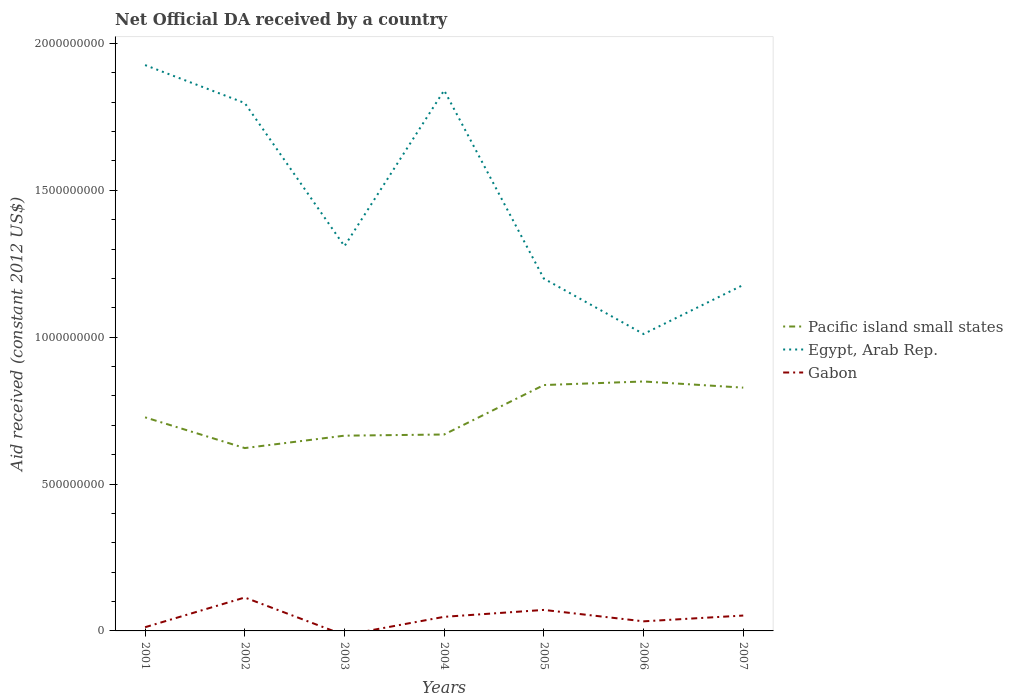How many different coloured lines are there?
Your answer should be compact. 3. Across all years, what is the maximum net official development assistance aid received in Egypt, Arab Rep.?
Make the answer very short. 1.01e+09. What is the total net official development assistance aid received in Pacific island small states in the graph?
Keep it short and to the point. -2.27e+08. What is the difference between the highest and the second highest net official development assistance aid received in Egypt, Arab Rep.?
Your response must be concise. 9.16e+08. What is the difference between the highest and the lowest net official development assistance aid received in Egypt, Arab Rep.?
Make the answer very short. 3. Is the net official development assistance aid received in Egypt, Arab Rep. strictly greater than the net official development assistance aid received in Pacific island small states over the years?
Provide a short and direct response. No. How many lines are there?
Your answer should be compact. 3. Where does the legend appear in the graph?
Offer a terse response. Center right. How are the legend labels stacked?
Offer a very short reply. Vertical. What is the title of the graph?
Your answer should be compact. Net Official DA received by a country. Does "Kiribati" appear as one of the legend labels in the graph?
Your answer should be very brief. No. What is the label or title of the X-axis?
Your answer should be compact. Years. What is the label or title of the Y-axis?
Ensure brevity in your answer.  Aid received (constant 2012 US$). What is the Aid received (constant 2012 US$) in Pacific island small states in 2001?
Provide a short and direct response. 7.27e+08. What is the Aid received (constant 2012 US$) of Egypt, Arab Rep. in 2001?
Provide a short and direct response. 1.93e+09. What is the Aid received (constant 2012 US$) of Gabon in 2001?
Offer a terse response. 1.26e+07. What is the Aid received (constant 2012 US$) in Pacific island small states in 2002?
Ensure brevity in your answer.  6.22e+08. What is the Aid received (constant 2012 US$) in Egypt, Arab Rep. in 2002?
Keep it short and to the point. 1.80e+09. What is the Aid received (constant 2012 US$) of Gabon in 2002?
Provide a succinct answer. 1.14e+08. What is the Aid received (constant 2012 US$) of Pacific island small states in 2003?
Ensure brevity in your answer.  6.65e+08. What is the Aid received (constant 2012 US$) in Egypt, Arab Rep. in 2003?
Make the answer very short. 1.31e+09. What is the Aid received (constant 2012 US$) of Gabon in 2003?
Provide a short and direct response. 0. What is the Aid received (constant 2012 US$) of Pacific island small states in 2004?
Give a very brief answer. 6.69e+08. What is the Aid received (constant 2012 US$) in Egypt, Arab Rep. in 2004?
Provide a succinct answer. 1.84e+09. What is the Aid received (constant 2012 US$) of Gabon in 2004?
Keep it short and to the point. 4.80e+07. What is the Aid received (constant 2012 US$) in Pacific island small states in 2005?
Keep it short and to the point. 8.37e+08. What is the Aid received (constant 2012 US$) in Egypt, Arab Rep. in 2005?
Give a very brief answer. 1.20e+09. What is the Aid received (constant 2012 US$) of Gabon in 2005?
Your answer should be very brief. 7.15e+07. What is the Aid received (constant 2012 US$) of Pacific island small states in 2006?
Your answer should be very brief. 8.49e+08. What is the Aid received (constant 2012 US$) of Egypt, Arab Rep. in 2006?
Offer a very short reply. 1.01e+09. What is the Aid received (constant 2012 US$) of Gabon in 2006?
Offer a very short reply. 3.27e+07. What is the Aid received (constant 2012 US$) of Pacific island small states in 2007?
Your response must be concise. 8.28e+08. What is the Aid received (constant 2012 US$) in Egypt, Arab Rep. in 2007?
Keep it short and to the point. 1.18e+09. What is the Aid received (constant 2012 US$) of Gabon in 2007?
Make the answer very short. 5.24e+07. Across all years, what is the maximum Aid received (constant 2012 US$) of Pacific island small states?
Offer a terse response. 8.49e+08. Across all years, what is the maximum Aid received (constant 2012 US$) in Egypt, Arab Rep.?
Your answer should be very brief. 1.93e+09. Across all years, what is the maximum Aid received (constant 2012 US$) of Gabon?
Ensure brevity in your answer.  1.14e+08. Across all years, what is the minimum Aid received (constant 2012 US$) of Pacific island small states?
Provide a succinct answer. 6.22e+08. Across all years, what is the minimum Aid received (constant 2012 US$) of Egypt, Arab Rep.?
Your answer should be very brief. 1.01e+09. Across all years, what is the minimum Aid received (constant 2012 US$) in Gabon?
Offer a very short reply. 0. What is the total Aid received (constant 2012 US$) in Pacific island small states in the graph?
Ensure brevity in your answer.  5.20e+09. What is the total Aid received (constant 2012 US$) in Egypt, Arab Rep. in the graph?
Your answer should be compact. 1.03e+1. What is the total Aid received (constant 2012 US$) of Gabon in the graph?
Provide a succinct answer. 3.31e+08. What is the difference between the Aid received (constant 2012 US$) of Pacific island small states in 2001 and that in 2002?
Your response must be concise. 1.05e+08. What is the difference between the Aid received (constant 2012 US$) of Egypt, Arab Rep. in 2001 and that in 2002?
Your answer should be very brief. 1.29e+08. What is the difference between the Aid received (constant 2012 US$) of Gabon in 2001 and that in 2002?
Make the answer very short. -1.01e+08. What is the difference between the Aid received (constant 2012 US$) in Pacific island small states in 2001 and that in 2003?
Provide a short and direct response. 6.24e+07. What is the difference between the Aid received (constant 2012 US$) in Egypt, Arab Rep. in 2001 and that in 2003?
Your answer should be compact. 6.17e+08. What is the difference between the Aid received (constant 2012 US$) of Pacific island small states in 2001 and that in 2004?
Keep it short and to the point. 5.84e+07. What is the difference between the Aid received (constant 2012 US$) of Egypt, Arab Rep. in 2001 and that in 2004?
Ensure brevity in your answer.  8.60e+07. What is the difference between the Aid received (constant 2012 US$) of Gabon in 2001 and that in 2004?
Your answer should be compact. -3.54e+07. What is the difference between the Aid received (constant 2012 US$) in Pacific island small states in 2001 and that in 2005?
Your answer should be very brief. -1.10e+08. What is the difference between the Aid received (constant 2012 US$) of Egypt, Arab Rep. in 2001 and that in 2005?
Make the answer very short. 7.27e+08. What is the difference between the Aid received (constant 2012 US$) in Gabon in 2001 and that in 2005?
Your response must be concise. -5.89e+07. What is the difference between the Aid received (constant 2012 US$) of Pacific island small states in 2001 and that in 2006?
Provide a short and direct response. -1.22e+08. What is the difference between the Aid received (constant 2012 US$) in Egypt, Arab Rep. in 2001 and that in 2006?
Offer a terse response. 9.16e+08. What is the difference between the Aid received (constant 2012 US$) of Gabon in 2001 and that in 2006?
Provide a succinct answer. -2.00e+07. What is the difference between the Aid received (constant 2012 US$) in Pacific island small states in 2001 and that in 2007?
Your answer should be very brief. -1.01e+08. What is the difference between the Aid received (constant 2012 US$) in Egypt, Arab Rep. in 2001 and that in 2007?
Your response must be concise. 7.49e+08. What is the difference between the Aid received (constant 2012 US$) of Gabon in 2001 and that in 2007?
Your response must be concise. -3.98e+07. What is the difference between the Aid received (constant 2012 US$) of Pacific island small states in 2002 and that in 2003?
Ensure brevity in your answer.  -4.23e+07. What is the difference between the Aid received (constant 2012 US$) in Egypt, Arab Rep. in 2002 and that in 2003?
Offer a very short reply. 4.87e+08. What is the difference between the Aid received (constant 2012 US$) in Pacific island small states in 2002 and that in 2004?
Your response must be concise. -4.62e+07. What is the difference between the Aid received (constant 2012 US$) of Egypt, Arab Rep. in 2002 and that in 2004?
Offer a very short reply. -4.33e+07. What is the difference between the Aid received (constant 2012 US$) in Gabon in 2002 and that in 2004?
Your response must be concise. 6.58e+07. What is the difference between the Aid received (constant 2012 US$) of Pacific island small states in 2002 and that in 2005?
Provide a short and direct response. -2.15e+08. What is the difference between the Aid received (constant 2012 US$) in Egypt, Arab Rep. in 2002 and that in 2005?
Make the answer very short. 5.98e+08. What is the difference between the Aid received (constant 2012 US$) of Gabon in 2002 and that in 2005?
Make the answer very short. 4.23e+07. What is the difference between the Aid received (constant 2012 US$) of Pacific island small states in 2002 and that in 2006?
Offer a very short reply. -2.27e+08. What is the difference between the Aid received (constant 2012 US$) in Egypt, Arab Rep. in 2002 and that in 2006?
Provide a succinct answer. 7.86e+08. What is the difference between the Aid received (constant 2012 US$) in Gabon in 2002 and that in 2006?
Keep it short and to the point. 8.11e+07. What is the difference between the Aid received (constant 2012 US$) of Pacific island small states in 2002 and that in 2007?
Make the answer very short. -2.06e+08. What is the difference between the Aid received (constant 2012 US$) in Egypt, Arab Rep. in 2002 and that in 2007?
Keep it short and to the point. 6.19e+08. What is the difference between the Aid received (constant 2012 US$) in Gabon in 2002 and that in 2007?
Keep it short and to the point. 6.14e+07. What is the difference between the Aid received (constant 2012 US$) in Pacific island small states in 2003 and that in 2004?
Your response must be concise. -3.98e+06. What is the difference between the Aid received (constant 2012 US$) in Egypt, Arab Rep. in 2003 and that in 2004?
Keep it short and to the point. -5.31e+08. What is the difference between the Aid received (constant 2012 US$) of Pacific island small states in 2003 and that in 2005?
Make the answer very short. -1.72e+08. What is the difference between the Aid received (constant 2012 US$) of Egypt, Arab Rep. in 2003 and that in 2005?
Ensure brevity in your answer.  1.10e+08. What is the difference between the Aid received (constant 2012 US$) in Pacific island small states in 2003 and that in 2006?
Offer a very short reply. -1.84e+08. What is the difference between the Aid received (constant 2012 US$) in Egypt, Arab Rep. in 2003 and that in 2006?
Provide a succinct answer. 2.99e+08. What is the difference between the Aid received (constant 2012 US$) in Pacific island small states in 2003 and that in 2007?
Keep it short and to the point. -1.64e+08. What is the difference between the Aid received (constant 2012 US$) in Egypt, Arab Rep. in 2003 and that in 2007?
Give a very brief answer. 1.32e+08. What is the difference between the Aid received (constant 2012 US$) of Pacific island small states in 2004 and that in 2005?
Keep it short and to the point. -1.68e+08. What is the difference between the Aid received (constant 2012 US$) of Egypt, Arab Rep. in 2004 and that in 2005?
Your answer should be compact. 6.41e+08. What is the difference between the Aid received (constant 2012 US$) of Gabon in 2004 and that in 2005?
Provide a succinct answer. -2.35e+07. What is the difference between the Aid received (constant 2012 US$) in Pacific island small states in 2004 and that in 2006?
Give a very brief answer. -1.81e+08. What is the difference between the Aid received (constant 2012 US$) of Egypt, Arab Rep. in 2004 and that in 2006?
Provide a succinct answer. 8.30e+08. What is the difference between the Aid received (constant 2012 US$) in Gabon in 2004 and that in 2006?
Keep it short and to the point. 1.53e+07. What is the difference between the Aid received (constant 2012 US$) in Pacific island small states in 2004 and that in 2007?
Provide a succinct answer. -1.60e+08. What is the difference between the Aid received (constant 2012 US$) of Egypt, Arab Rep. in 2004 and that in 2007?
Offer a very short reply. 6.63e+08. What is the difference between the Aid received (constant 2012 US$) of Gabon in 2004 and that in 2007?
Offer a very short reply. -4.38e+06. What is the difference between the Aid received (constant 2012 US$) of Pacific island small states in 2005 and that in 2006?
Ensure brevity in your answer.  -1.22e+07. What is the difference between the Aid received (constant 2012 US$) of Egypt, Arab Rep. in 2005 and that in 2006?
Make the answer very short. 1.89e+08. What is the difference between the Aid received (constant 2012 US$) of Gabon in 2005 and that in 2006?
Ensure brevity in your answer.  3.88e+07. What is the difference between the Aid received (constant 2012 US$) in Pacific island small states in 2005 and that in 2007?
Provide a succinct answer. 8.79e+06. What is the difference between the Aid received (constant 2012 US$) in Egypt, Arab Rep. in 2005 and that in 2007?
Provide a succinct answer. 2.15e+07. What is the difference between the Aid received (constant 2012 US$) of Gabon in 2005 and that in 2007?
Offer a terse response. 1.91e+07. What is the difference between the Aid received (constant 2012 US$) of Pacific island small states in 2006 and that in 2007?
Offer a terse response. 2.10e+07. What is the difference between the Aid received (constant 2012 US$) of Egypt, Arab Rep. in 2006 and that in 2007?
Your answer should be very brief. -1.67e+08. What is the difference between the Aid received (constant 2012 US$) in Gabon in 2006 and that in 2007?
Your response must be concise. -1.97e+07. What is the difference between the Aid received (constant 2012 US$) of Pacific island small states in 2001 and the Aid received (constant 2012 US$) of Egypt, Arab Rep. in 2002?
Keep it short and to the point. -1.07e+09. What is the difference between the Aid received (constant 2012 US$) in Pacific island small states in 2001 and the Aid received (constant 2012 US$) in Gabon in 2002?
Keep it short and to the point. 6.13e+08. What is the difference between the Aid received (constant 2012 US$) in Egypt, Arab Rep. in 2001 and the Aid received (constant 2012 US$) in Gabon in 2002?
Your answer should be very brief. 1.81e+09. What is the difference between the Aid received (constant 2012 US$) in Pacific island small states in 2001 and the Aid received (constant 2012 US$) in Egypt, Arab Rep. in 2003?
Give a very brief answer. -5.83e+08. What is the difference between the Aid received (constant 2012 US$) in Pacific island small states in 2001 and the Aid received (constant 2012 US$) in Egypt, Arab Rep. in 2004?
Your answer should be compact. -1.11e+09. What is the difference between the Aid received (constant 2012 US$) in Pacific island small states in 2001 and the Aid received (constant 2012 US$) in Gabon in 2004?
Provide a short and direct response. 6.79e+08. What is the difference between the Aid received (constant 2012 US$) of Egypt, Arab Rep. in 2001 and the Aid received (constant 2012 US$) of Gabon in 2004?
Your answer should be very brief. 1.88e+09. What is the difference between the Aid received (constant 2012 US$) in Pacific island small states in 2001 and the Aid received (constant 2012 US$) in Egypt, Arab Rep. in 2005?
Ensure brevity in your answer.  -4.72e+08. What is the difference between the Aid received (constant 2012 US$) of Pacific island small states in 2001 and the Aid received (constant 2012 US$) of Gabon in 2005?
Offer a very short reply. 6.56e+08. What is the difference between the Aid received (constant 2012 US$) of Egypt, Arab Rep. in 2001 and the Aid received (constant 2012 US$) of Gabon in 2005?
Make the answer very short. 1.85e+09. What is the difference between the Aid received (constant 2012 US$) of Pacific island small states in 2001 and the Aid received (constant 2012 US$) of Egypt, Arab Rep. in 2006?
Keep it short and to the point. -2.84e+08. What is the difference between the Aid received (constant 2012 US$) of Pacific island small states in 2001 and the Aid received (constant 2012 US$) of Gabon in 2006?
Make the answer very short. 6.94e+08. What is the difference between the Aid received (constant 2012 US$) in Egypt, Arab Rep. in 2001 and the Aid received (constant 2012 US$) in Gabon in 2006?
Provide a short and direct response. 1.89e+09. What is the difference between the Aid received (constant 2012 US$) in Pacific island small states in 2001 and the Aid received (constant 2012 US$) in Egypt, Arab Rep. in 2007?
Your response must be concise. -4.51e+08. What is the difference between the Aid received (constant 2012 US$) of Pacific island small states in 2001 and the Aid received (constant 2012 US$) of Gabon in 2007?
Give a very brief answer. 6.75e+08. What is the difference between the Aid received (constant 2012 US$) of Egypt, Arab Rep. in 2001 and the Aid received (constant 2012 US$) of Gabon in 2007?
Keep it short and to the point. 1.87e+09. What is the difference between the Aid received (constant 2012 US$) of Pacific island small states in 2002 and the Aid received (constant 2012 US$) of Egypt, Arab Rep. in 2003?
Offer a terse response. -6.87e+08. What is the difference between the Aid received (constant 2012 US$) of Pacific island small states in 2002 and the Aid received (constant 2012 US$) of Egypt, Arab Rep. in 2004?
Make the answer very short. -1.22e+09. What is the difference between the Aid received (constant 2012 US$) of Pacific island small states in 2002 and the Aid received (constant 2012 US$) of Gabon in 2004?
Keep it short and to the point. 5.75e+08. What is the difference between the Aid received (constant 2012 US$) in Egypt, Arab Rep. in 2002 and the Aid received (constant 2012 US$) in Gabon in 2004?
Give a very brief answer. 1.75e+09. What is the difference between the Aid received (constant 2012 US$) of Pacific island small states in 2002 and the Aid received (constant 2012 US$) of Egypt, Arab Rep. in 2005?
Offer a terse response. -5.77e+08. What is the difference between the Aid received (constant 2012 US$) in Pacific island small states in 2002 and the Aid received (constant 2012 US$) in Gabon in 2005?
Keep it short and to the point. 5.51e+08. What is the difference between the Aid received (constant 2012 US$) of Egypt, Arab Rep. in 2002 and the Aid received (constant 2012 US$) of Gabon in 2005?
Your answer should be compact. 1.73e+09. What is the difference between the Aid received (constant 2012 US$) of Pacific island small states in 2002 and the Aid received (constant 2012 US$) of Egypt, Arab Rep. in 2006?
Ensure brevity in your answer.  -3.88e+08. What is the difference between the Aid received (constant 2012 US$) of Pacific island small states in 2002 and the Aid received (constant 2012 US$) of Gabon in 2006?
Make the answer very short. 5.90e+08. What is the difference between the Aid received (constant 2012 US$) of Egypt, Arab Rep. in 2002 and the Aid received (constant 2012 US$) of Gabon in 2006?
Make the answer very short. 1.76e+09. What is the difference between the Aid received (constant 2012 US$) of Pacific island small states in 2002 and the Aid received (constant 2012 US$) of Egypt, Arab Rep. in 2007?
Give a very brief answer. -5.55e+08. What is the difference between the Aid received (constant 2012 US$) of Pacific island small states in 2002 and the Aid received (constant 2012 US$) of Gabon in 2007?
Ensure brevity in your answer.  5.70e+08. What is the difference between the Aid received (constant 2012 US$) of Egypt, Arab Rep. in 2002 and the Aid received (constant 2012 US$) of Gabon in 2007?
Offer a terse response. 1.74e+09. What is the difference between the Aid received (constant 2012 US$) of Pacific island small states in 2003 and the Aid received (constant 2012 US$) of Egypt, Arab Rep. in 2004?
Your response must be concise. -1.18e+09. What is the difference between the Aid received (constant 2012 US$) of Pacific island small states in 2003 and the Aid received (constant 2012 US$) of Gabon in 2004?
Provide a short and direct response. 6.17e+08. What is the difference between the Aid received (constant 2012 US$) in Egypt, Arab Rep. in 2003 and the Aid received (constant 2012 US$) in Gabon in 2004?
Give a very brief answer. 1.26e+09. What is the difference between the Aid received (constant 2012 US$) in Pacific island small states in 2003 and the Aid received (constant 2012 US$) in Egypt, Arab Rep. in 2005?
Ensure brevity in your answer.  -5.35e+08. What is the difference between the Aid received (constant 2012 US$) in Pacific island small states in 2003 and the Aid received (constant 2012 US$) in Gabon in 2005?
Provide a short and direct response. 5.93e+08. What is the difference between the Aid received (constant 2012 US$) in Egypt, Arab Rep. in 2003 and the Aid received (constant 2012 US$) in Gabon in 2005?
Your answer should be very brief. 1.24e+09. What is the difference between the Aid received (constant 2012 US$) in Pacific island small states in 2003 and the Aid received (constant 2012 US$) in Egypt, Arab Rep. in 2006?
Your answer should be very brief. -3.46e+08. What is the difference between the Aid received (constant 2012 US$) of Pacific island small states in 2003 and the Aid received (constant 2012 US$) of Gabon in 2006?
Make the answer very short. 6.32e+08. What is the difference between the Aid received (constant 2012 US$) in Egypt, Arab Rep. in 2003 and the Aid received (constant 2012 US$) in Gabon in 2006?
Make the answer very short. 1.28e+09. What is the difference between the Aid received (constant 2012 US$) of Pacific island small states in 2003 and the Aid received (constant 2012 US$) of Egypt, Arab Rep. in 2007?
Provide a short and direct response. -5.13e+08. What is the difference between the Aid received (constant 2012 US$) of Pacific island small states in 2003 and the Aid received (constant 2012 US$) of Gabon in 2007?
Provide a succinct answer. 6.12e+08. What is the difference between the Aid received (constant 2012 US$) of Egypt, Arab Rep. in 2003 and the Aid received (constant 2012 US$) of Gabon in 2007?
Ensure brevity in your answer.  1.26e+09. What is the difference between the Aid received (constant 2012 US$) in Pacific island small states in 2004 and the Aid received (constant 2012 US$) in Egypt, Arab Rep. in 2005?
Your answer should be compact. -5.31e+08. What is the difference between the Aid received (constant 2012 US$) of Pacific island small states in 2004 and the Aid received (constant 2012 US$) of Gabon in 2005?
Make the answer very short. 5.97e+08. What is the difference between the Aid received (constant 2012 US$) of Egypt, Arab Rep. in 2004 and the Aid received (constant 2012 US$) of Gabon in 2005?
Your response must be concise. 1.77e+09. What is the difference between the Aid received (constant 2012 US$) of Pacific island small states in 2004 and the Aid received (constant 2012 US$) of Egypt, Arab Rep. in 2006?
Make the answer very short. -3.42e+08. What is the difference between the Aid received (constant 2012 US$) in Pacific island small states in 2004 and the Aid received (constant 2012 US$) in Gabon in 2006?
Make the answer very short. 6.36e+08. What is the difference between the Aid received (constant 2012 US$) of Egypt, Arab Rep. in 2004 and the Aid received (constant 2012 US$) of Gabon in 2006?
Ensure brevity in your answer.  1.81e+09. What is the difference between the Aid received (constant 2012 US$) in Pacific island small states in 2004 and the Aid received (constant 2012 US$) in Egypt, Arab Rep. in 2007?
Provide a short and direct response. -5.09e+08. What is the difference between the Aid received (constant 2012 US$) in Pacific island small states in 2004 and the Aid received (constant 2012 US$) in Gabon in 2007?
Your answer should be compact. 6.16e+08. What is the difference between the Aid received (constant 2012 US$) of Egypt, Arab Rep. in 2004 and the Aid received (constant 2012 US$) of Gabon in 2007?
Provide a succinct answer. 1.79e+09. What is the difference between the Aid received (constant 2012 US$) in Pacific island small states in 2005 and the Aid received (constant 2012 US$) in Egypt, Arab Rep. in 2006?
Offer a very short reply. -1.74e+08. What is the difference between the Aid received (constant 2012 US$) of Pacific island small states in 2005 and the Aid received (constant 2012 US$) of Gabon in 2006?
Offer a very short reply. 8.04e+08. What is the difference between the Aid received (constant 2012 US$) in Egypt, Arab Rep. in 2005 and the Aid received (constant 2012 US$) in Gabon in 2006?
Provide a short and direct response. 1.17e+09. What is the difference between the Aid received (constant 2012 US$) of Pacific island small states in 2005 and the Aid received (constant 2012 US$) of Egypt, Arab Rep. in 2007?
Make the answer very short. -3.41e+08. What is the difference between the Aid received (constant 2012 US$) in Pacific island small states in 2005 and the Aid received (constant 2012 US$) in Gabon in 2007?
Your answer should be very brief. 7.85e+08. What is the difference between the Aid received (constant 2012 US$) in Egypt, Arab Rep. in 2005 and the Aid received (constant 2012 US$) in Gabon in 2007?
Provide a short and direct response. 1.15e+09. What is the difference between the Aid received (constant 2012 US$) in Pacific island small states in 2006 and the Aid received (constant 2012 US$) in Egypt, Arab Rep. in 2007?
Offer a very short reply. -3.29e+08. What is the difference between the Aid received (constant 2012 US$) of Pacific island small states in 2006 and the Aid received (constant 2012 US$) of Gabon in 2007?
Your answer should be compact. 7.97e+08. What is the difference between the Aid received (constant 2012 US$) of Egypt, Arab Rep. in 2006 and the Aid received (constant 2012 US$) of Gabon in 2007?
Give a very brief answer. 9.58e+08. What is the average Aid received (constant 2012 US$) of Pacific island small states per year?
Keep it short and to the point. 7.43e+08. What is the average Aid received (constant 2012 US$) of Egypt, Arab Rep. per year?
Your answer should be compact. 1.47e+09. What is the average Aid received (constant 2012 US$) of Gabon per year?
Provide a short and direct response. 4.73e+07. In the year 2001, what is the difference between the Aid received (constant 2012 US$) in Pacific island small states and Aid received (constant 2012 US$) in Egypt, Arab Rep.?
Provide a succinct answer. -1.20e+09. In the year 2001, what is the difference between the Aid received (constant 2012 US$) in Pacific island small states and Aid received (constant 2012 US$) in Gabon?
Provide a succinct answer. 7.15e+08. In the year 2001, what is the difference between the Aid received (constant 2012 US$) in Egypt, Arab Rep. and Aid received (constant 2012 US$) in Gabon?
Your answer should be very brief. 1.91e+09. In the year 2002, what is the difference between the Aid received (constant 2012 US$) in Pacific island small states and Aid received (constant 2012 US$) in Egypt, Arab Rep.?
Give a very brief answer. -1.17e+09. In the year 2002, what is the difference between the Aid received (constant 2012 US$) in Pacific island small states and Aid received (constant 2012 US$) in Gabon?
Keep it short and to the point. 5.09e+08. In the year 2002, what is the difference between the Aid received (constant 2012 US$) of Egypt, Arab Rep. and Aid received (constant 2012 US$) of Gabon?
Offer a very short reply. 1.68e+09. In the year 2003, what is the difference between the Aid received (constant 2012 US$) of Pacific island small states and Aid received (constant 2012 US$) of Egypt, Arab Rep.?
Provide a short and direct response. -6.45e+08. In the year 2004, what is the difference between the Aid received (constant 2012 US$) of Pacific island small states and Aid received (constant 2012 US$) of Egypt, Arab Rep.?
Provide a short and direct response. -1.17e+09. In the year 2004, what is the difference between the Aid received (constant 2012 US$) in Pacific island small states and Aid received (constant 2012 US$) in Gabon?
Keep it short and to the point. 6.21e+08. In the year 2004, what is the difference between the Aid received (constant 2012 US$) in Egypt, Arab Rep. and Aid received (constant 2012 US$) in Gabon?
Your response must be concise. 1.79e+09. In the year 2005, what is the difference between the Aid received (constant 2012 US$) in Pacific island small states and Aid received (constant 2012 US$) in Egypt, Arab Rep.?
Provide a succinct answer. -3.62e+08. In the year 2005, what is the difference between the Aid received (constant 2012 US$) of Pacific island small states and Aid received (constant 2012 US$) of Gabon?
Provide a succinct answer. 7.66e+08. In the year 2005, what is the difference between the Aid received (constant 2012 US$) of Egypt, Arab Rep. and Aid received (constant 2012 US$) of Gabon?
Your response must be concise. 1.13e+09. In the year 2006, what is the difference between the Aid received (constant 2012 US$) of Pacific island small states and Aid received (constant 2012 US$) of Egypt, Arab Rep.?
Your response must be concise. -1.62e+08. In the year 2006, what is the difference between the Aid received (constant 2012 US$) in Pacific island small states and Aid received (constant 2012 US$) in Gabon?
Offer a very short reply. 8.17e+08. In the year 2006, what is the difference between the Aid received (constant 2012 US$) of Egypt, Arab Rep. and Aid received (constant 2012 US$) of Gabon?
Provide a short and direct response. 9.78e+08. In the year 2007, what is the difference between the Aid received (constant 2012 US$) in Pacific island small states and Aid received (constant 2012 US$) in Egypt, Arab Rep.?
Provide a succinct answer. -3.50e+08. In the year 2007, what is the difference between the Aid received (constant 2012 US$) of Pacific island small states and Aid received (constant 2012 US$) of Gabon?
Provide a succinct answer. 7.76e+08. In the year 2007, what is the difference between the Aid received (constant 2012 US$) of Egypt, Arab Rep. and Aid received (constant 2012 US$) of Gabon?
Offer a terse response. 1.13e+09. What is the ratio of the Aid received (constant 2012 US$) of Pacific island small states in 2001 to that in 2002?
Your answer should be compact. 1.17. What is the ratio of the Aid received (constant 2012 US$) in Egypt, Arab Rep. in 2001 to that in 2002?
Your response must be concise. 1.07. What is the ratio of the Aid received (constant 2012 US$) of Gabon in 2001 to that in 2002?
Keep it short and to the point. 0.11. What is the ratio of the Aid received (constant 2012 US$) in Pacific island small states in 2001 to that in 2003?
Offer a very short reply. 1.09. What is the ratio of the Aid received (constant 2012 US$) of Egypt, Arab Rep. in 2001 to that in 2003?
Your answer should be compact. 1.47. What is the ratio of the Aid received (constant 2012 US$) of Pacific island small states in 2001 to that in 2004?
Keep it short and to the point. 1.09. What is the ratio of the Aid received (constant 2012 US$) of Egypt, Arab Rep. in 2001 to that in 2004?
Offer a terse response. 1.05. What is the ratio of the Aid received (constant 2012 US$) in Gabon in 2001 to that in 2004?
Provide a succinct answer. 0.26. What is the ratio of the Aid received (constant 2012 US$) of Pacific island small states in 2001 to that in 2005?
Offer a very short reply. 0.87. What is the ratio of the Aid received (constant 2012 US$) in Egypt, Arab Rep. in 2001 to that in 2005?
Make the answer very short. 1.61. What is the ratio of the Aid received (constant 2012 US$) in Gabon in 2001 to that in 2005?
Make the answer very short. 0.18. What is the ratio of the Aid received (constant 2012 US$) of Pacific island small states in 2001 to that in 2006?
Make the answer very short. 0.86. What is the ratio of the Aid received (constant 2012 US$) in Egypt, Arab Rep. in 2001 to that in 2006?
Keep it short and to the point. 1.91. What is the ratio of the Aid received (constant 2012 US$) of Gabon in 2001 to that in 2006?
Make the answer very short. 0.39. What is the ratio of the Aid received (constant 2012 US$) of Pacific island small states in 2001 to that in 2007?
Offer a terse response. 0.88. What is the ratio of the Aid received (constant 2012 US$) of Egypt, Arab Rep. in 2001 to that in 2007?
Offer a very short reply. 1.64. What is the ratio of the Aid received (constant 2012 US$) in Gabon in 2001 to that in 2007?
Offer a very short reply. 0.24. What is the ratio of the Aid received (constant 2012 US$) of Pacific island small states in 2002 to that in 2003?
Ensure brevity in your answer.  0.94. What is the ratio of the Aid received (constant 2012 US$) in Egypt, Arab Rep. in 2002 to that in 2003?
Keep it short and to the point. 1.37. What is the ratio of the Aid received (constant 2012 US$) of Pacific island small states in 2002 to that in 2004?
Offer a very short reply. 0.93. What is the ratio of the Aid received (constant 2012 US$) of Egypt, Arab Rep. in 2002 to that in 2004?
Provide a short and direct response. 0.98. What is the ratio of the Aid received (constant 2012 US$) in Gabon in 2002 to that in 2004?
Your response must be concise. 2.37. What is the ratio of the Aid received (constant 2012 US$) of Pacific island small states in 2002 to that in 2005?
Give a very brief answer. 0.74. What is the ratio of the Aid received (constant 2012 US$) in Egypt, Arab Rep. in 2002 to that in 2005?
Keep it short and to the point. 1.5. What is the ratio of the Aid received (constant 2012 US$) of Gabon in 2002 to that in 2005?
Offer a very short reply. 1.59. What is the ratio of the Aid received (constant 2012 US$) in Pacific island small states in 2002 to that in 2006?
Offer a terse response. 0.73. What is the ratio of the Aid received (constant 2012 US$) of Egypt, Arab Rep. in 2002 to that in 2006?
Provide a succinct answer. 1.78. What is the ratio of the Aid received (constant 2012 US$) of Gabon in 2002 to that in 2006?
Make the answer very short. 3.48. What is the ratio of the Aid received (constant 2012 US$) of Pacific island small states in 2002 to that in 2007?
Ensure brevity in your answer.  0.75. What is the ratio of the Aid received (constant 2012 US$) of Egypt, Arab Rep. in 2002 to that in 2007?
Give a very brief answer. 1.53. What is the ratio of the Aid received (constant 2012 US$) in Gabon in 2002 to that in 2007?
Ensure brevity in your answer.  2.17. What is the ratio of the Aid received (constant 2012 US$) of Egypt, Arab Rep. in 2003 to that in 2004?
Offer a terse response. 0.71. What is the ratio of the Aid received (constant 2012 US$) in Pacific island small states in 2003 to that in 2005?
Keep it short and to the point. 0.79. What is the ratio of the Aid received (constant 2012 US$) of Egypt, Arab Rep. in 2003 to that in 2005?
Provide a succinct answer. 1.09. What is the ratio of the Aid received (constant 2012 US$) of Pacific island small states in 2003 to that in 2006?
Your answer should be very brief. 0.78. What is the ratio of the Aid received (constant 2012 US$) of Egypt, Arab Rep. in 2003 to that in 2006?
Make the answer very short. 1.3. What is the ratio of the Aid received (constant 2012 US$) of Pacific island small states in 2003 to that in 2007?
Provide a short and direct response. 0.8. What is the ratio of the Aid received (constant 2012 US$) of Egypt, Arab Rep. in 2003 to that in 2007?
Your response must be concise. 1.11. What is the ratio of the Aid received (constant 2012 US$) in Pacific island small states in 2004 to that in 2005?
Make the answer very short. 0.8. What is the ratio of the Aid received (constant 2012 US$) in Egypt, Arab Rep. in 2004 to that in 2005?
Ensure brevity in your answer.  1.53. What is the ratio of the Aid received (constant 2012 US$) of Gabon in 2004 to that in 2005?
Your response must be concise. 0.67. What is the ratio of the Aid received (constant 2012 US$) of Pacific island small states in 2004 to that in 2006?
Ensure brevity in your answer.  0.79. What is the ratio of the Aid received (constant 2012 US$) of Egypt, Arab Rep. in 2004 to that in 2006?
Ensure brevity in your answer.  1.82. What is the ratio of the Aid received (constant 2012 US$) in Gabon in 2004 to that in 2006?
Give a very brief answer. 1.47. What is the ratio of the Aid received (constant 2012 US$) of Pacific island small states in 2004 to that in 2007?
Make the answer very short. 0.81. What is the ratio of the Aid received (constant 2012 US$) in Egypt, Arab Rep. in 2004 to that in 2007?
Ensure brevity in your answer.  1.56. What is the ratio of the Aid received (constant 2012 US$) of Gabon in 2004 to that in 2007?
Offer a very short reply. 0.92. What is the ratio of the Aid received (constant 2012 US$) in Pacific island small states in 2005 to that in 2006?
Give a very brief answer. 0.99. What is the ratio of the Aid received (constant 2012 US$) of Egypt, Arab Rep. in 2005 to that in 2006?
Make the answer very short. 1.19. What is the ratio of the Aid received (constant 2012 US$) in Gabon in 2005 to that in 2006?
Your response must be concise. 2.19. What is the ratio of the Aid received (constant 2012 US$) in Pacific island small states in 2005 to that in 2007?
Your answer should be very brief. 1.01. What is the ratio of the Aid received (constant 2012 US$) of Egypt, Arab Rep. in 2005 to that in 2007?
Offer a terse response. 1.02. What is the ratio of the Aid received (constant 2012 US$) of Gabon in 2005 to that in 2007?
Give a very brief answer. 1.37. What is the ratio of the Aid received (constant 2012 US$) of Pacific island small states in 2006 to that in 2007?
Offer a terse response. 1.03. What is the ratio of the Aid received (constant 2012 US$) of Egypt, Arab Rep. in 2006 to that in 2007?
Offer a very short reply. 0.86. What is the ratio of the Aid received (constant 2012 US$) of Gabon in 2006 to that in 2007?
Provide a succinct answer. 0.62. What is the difference between the highest and the second highest Aid received (constant 2012 US$) of Pacific island small states?
Ensure brevity in your answer.  1.22e+07. What is the difference between the highest and the second highest Aid received (constant 2012 US$) in Egypt, Arab Rep.?
Offer a very short reply. 8.60e+07. What is the difference between the highest and the second highest Aid received (constant 2012 US$) of Gabon?
Keep it short and to the point. 4.23e+07. What is the difference between the highest and the lowest Aid received (constant 2012 US$) in Pacific island small states?
Ensure brevity in your answer.  2.27e+08. What is the difference between the highest and the lowest Aid received (constant 2012 US$) in Egypt, Arab Rep.?
Offer a terse response. 9.16e+08. What is the difference between the highest and the lowest Aid received (constant 2012 US$) of Gabon?
Keep it short and to the point. 1.14e+08. 